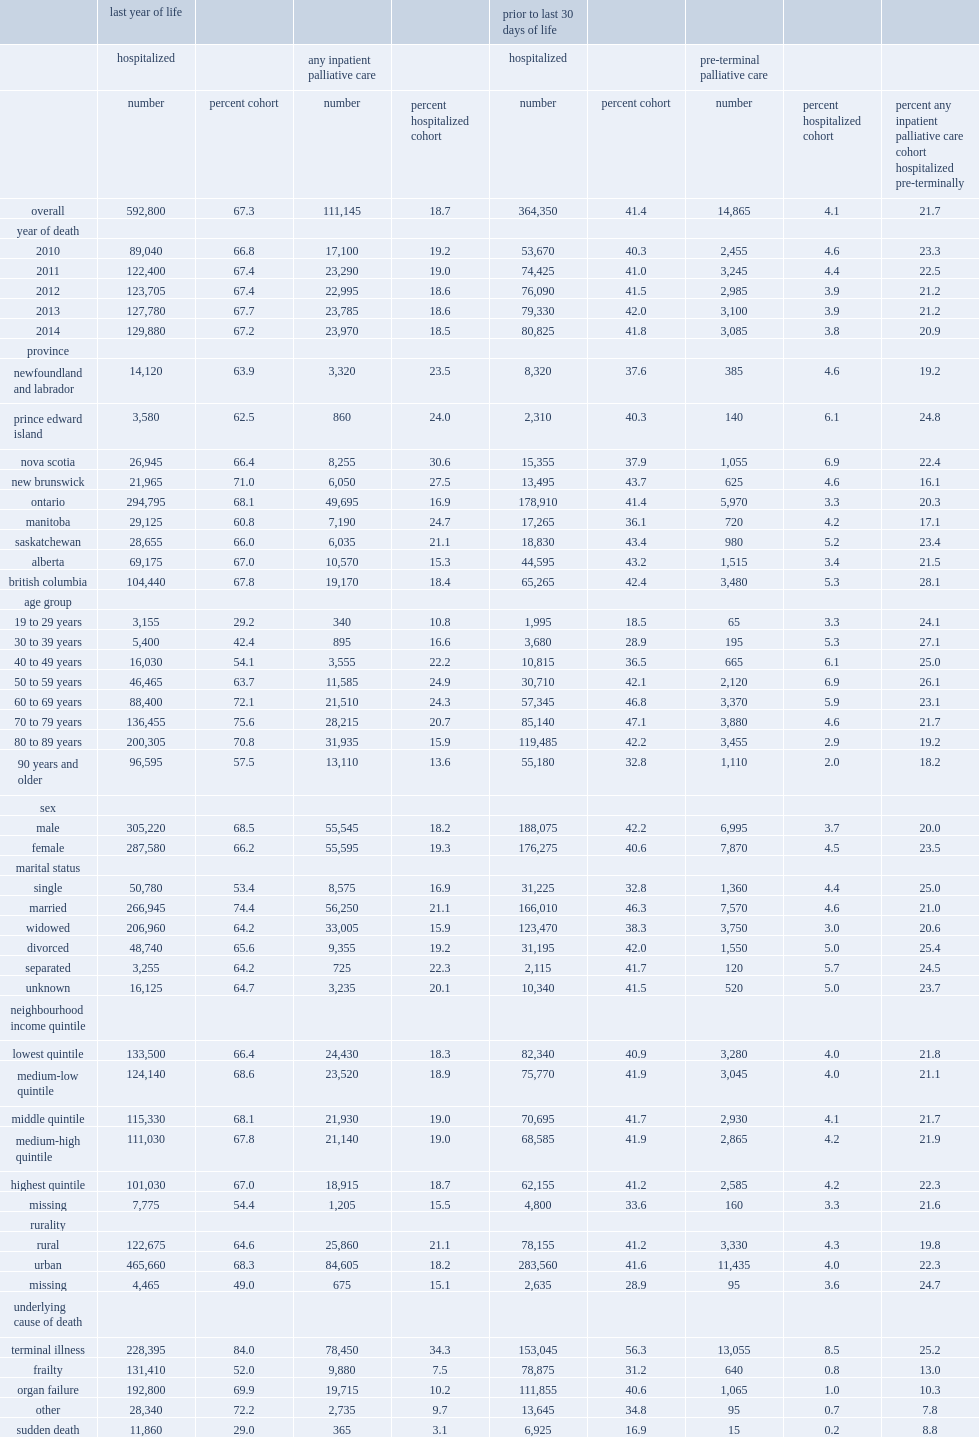What is the percentage of decedents who were hospitalized in their last year of life received inpatient pc consultation? 18.7. What is the percentage of decedents who were hospitalized in their last year of life received inpatient pc consultation in alberta? 15.3. What is the percentage of decedents who were hospitalized in their last year of life received inpatient pc consultation in nova scotia? 30.6. What is the percentage of decedents who were hospitalized in their last year of life received inpatient pc consultation in ontario? 16.9. What is the percentage of decedents who were hospitalized in their last year of life received inpatient pc consultation in british columbia? 18.4. Across the provinces, which place has the lowest rates in decedents who were hospitalized in their last year of life, received inpatient pc consultation? Alberta. Among those who received inpatient pc in their last year of life and who were hospitalized prior to their last 30 days of life, what is the percentage of decedents who received pre-terminal pc consultation? 21.7. Among those who received inpatient pc in their last year of life and who were hospitalized prior to their last 30 days of life, what is the percentage of decedents who received pre-terminal pc consultation in new brunswick? 16.1. Among those who received inpatient pc in their last year of life and who were hospitalized prior to their last 30 days of life, what is the percentage of decedents who received pre-terminal pc consultation in british columbia? 28.1. Among those who received inpatient pc in their last year of life and who were hospitalized prior to their last 30 days of life, what is the percentage of decedents who received pre-terminal pc consultation in 2010? 23.3. Among those who received inpatient pc in their last year of life and who were hospitalized prior to their last 30 days of life, what is the percentage of decedents who received pre-terminal pc consultation in 2014? 20.9. 